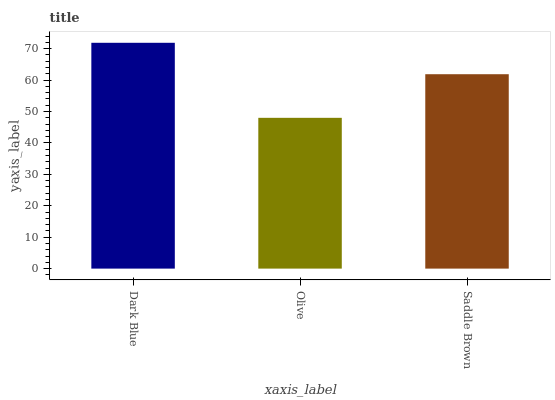Is Olive the minimum?
Answer yes or no. Yes. Is Dark Blue the maximum?
Answer yes or no. Yes. Is Saddle Brown the minimum?
Answer yes or no. No. Is Saddle Brown the maximum?
Answer yes or no. No. Is Saddle Brown greater than Olive?
Answer yes or no. Yes. Is Olive less than Saddle Brown?
Answer yes or no. Yes. Is Olive greater than Saddle Brown?
Answer yes or no. No. Is Saddle Brown less than Olive?
Answer yes or no. No. Is Saddle Brown the high median?
Answer yes or no. Yes. Is Saddle Brown the low median?
Answer yes or no. Yes. Is Olive the high median?
Answer yes or no. No. Is Olive the low median?
Answer yes or no. No. 